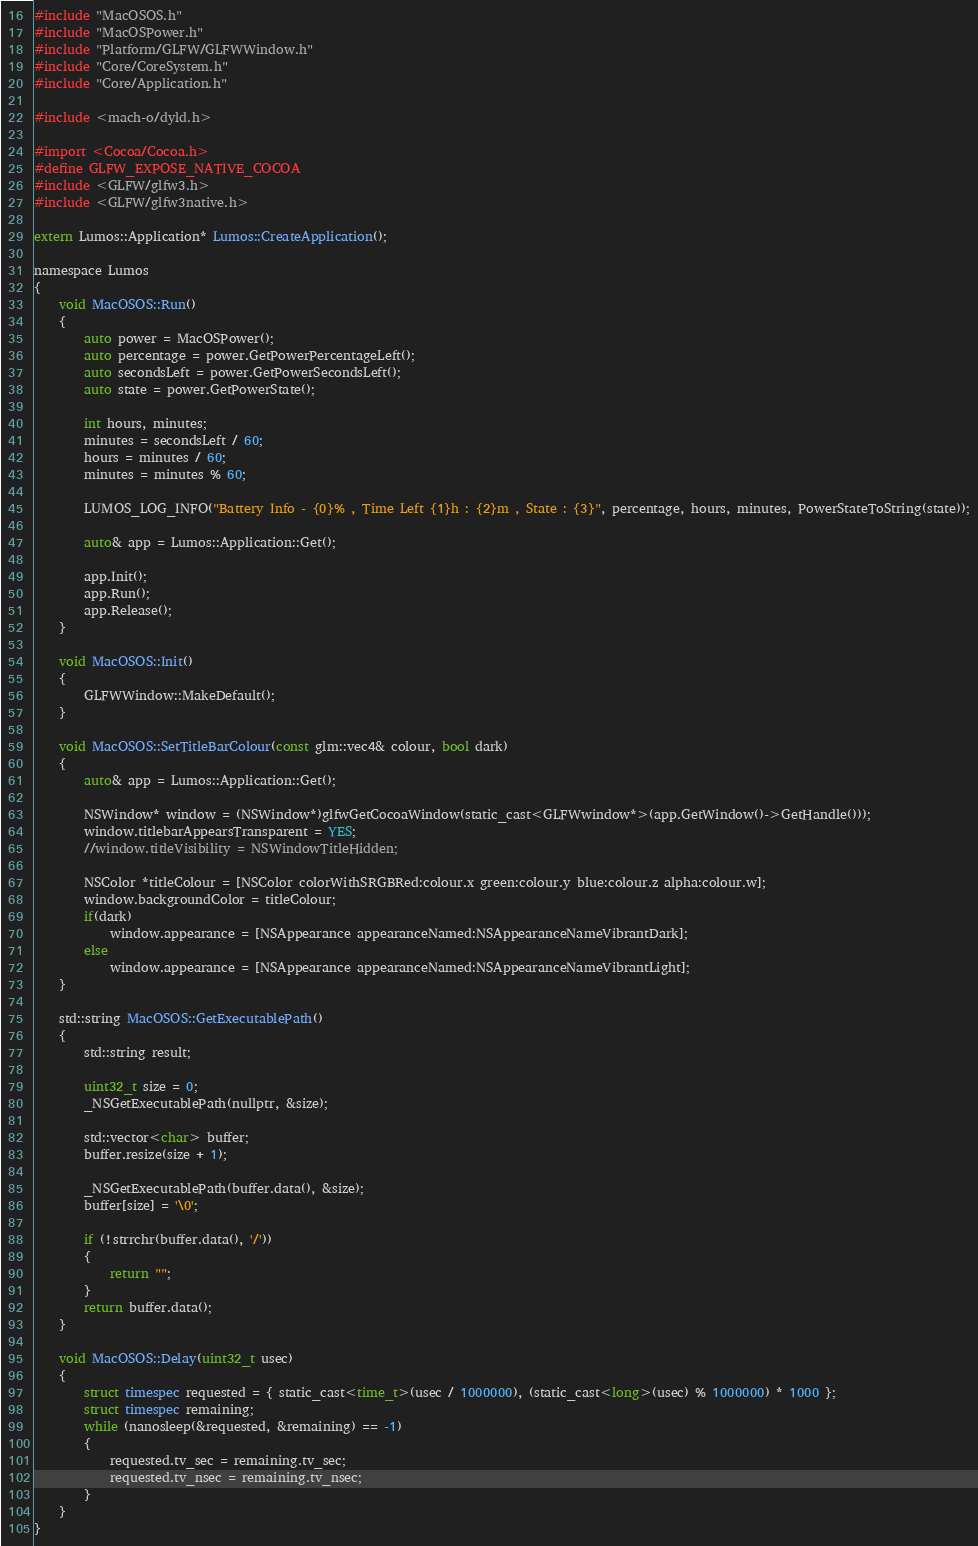<code> <loc_0><loc_0><loc_500><loc_500><_ObjectiveC_>#include "MacOSOS.h"
#include "MacOSPower.h"
#include "Platform/GLFW/GLFWWindow.h"
#include "Core/CoreSystem.h"
#include "Core/Application.h"

#include <mach-o/dyld.h>

#import <Cocoa/Cocoa.h>
#define GLFW_EXPOSE_NATIVE_COCOA
#include <GLFW/glfw3.h>
#include <GLFW/glfw3native.h>

extern Lumos::Application* Lumos::CreateApplication();

namespace Lumos
{
    void MacOSOS::Run()
    {
        auto power = MacOSPower();
        auto percentage = power.GetPowerPercentageLeft();
        auto secondsLeft = power.GetPowerSecondsLeft();
        auto state = power.GetPowerState();
		
		int hours, minutes;
		minutes = secondsLeft / 60;
		hours = minutes / 60;
		minutes = minutes % 60;
		
        LUMOS_LOG_INFO("Battery Info - {0}% , Time Left {1}h : {2}m , State : {3}", percentage, hours, minutes, PowerStateToString(state));

        auto& app = Lumos::Application::Get();

        app.Init();
        app.Run();
        app.Release();
    }

    void MacOSOS::Init()
    {
        GLFWWindow::MakeDefault();
    }

    void MacOSOS::SetTitleBarColour(const glm::vec4& colour, bool dark)
    {
        auto& app = Lumos::Application::Get();

        NSWindow* window = (NSWindow*)glfwGetCocoaWindow(static_cast<GLFWwindow*>(app.GetWindow()->GetHandle()));
        window.titlebarAppearsTransparent = YES;
        //window.titleVisibility = NSWindowTitleHidden;
        
        NSColor *titleColour = [NSColor colorWithSRGBRed:colour.x green:colour.y blue:colour.z alpha:colour.w];
        window.backgroundColor = titleColour;
        if(dark)
            window.appearance = [NSAppearance appearanceNamed:NSAppearanceNameVibrantDark];
        else
            window.appearance = [NSAppearance appearanceNamed:NSAppearanceNameVibrantLight];
    }

    std::string MacOSOS::GetExecutablePath()
    {
        std::string result;

        uint32_t size = 0;
        _NSGetExecutablePath(nullptr, &size);

        std::vector<char> buffer;
        buffer.resize(size + 1);

        _NSGetExecutablePath(buffer.data(), &size);
        buffer[size] = '\0';

        if (!strrchr(buffer.data(), '/'))
        {
            return "";
        }
        return buffer.data();
    }
	
	void MacOSOS::Delay(uint32_t usec)
	{
		struct timespec requested = { static_cast<time_t>(usec / 1000000), (static_cast<long>(usec) % 1000000) * 1000 };
		struct timespec remaining;
		while (nanosleep(&requested, &remaining) == -1)
		{
			requested.tv_sec = remaining.tv_sec;
			requested.tv_nsec = remaining.tv_nsec;
		}
	}
}
</code> 